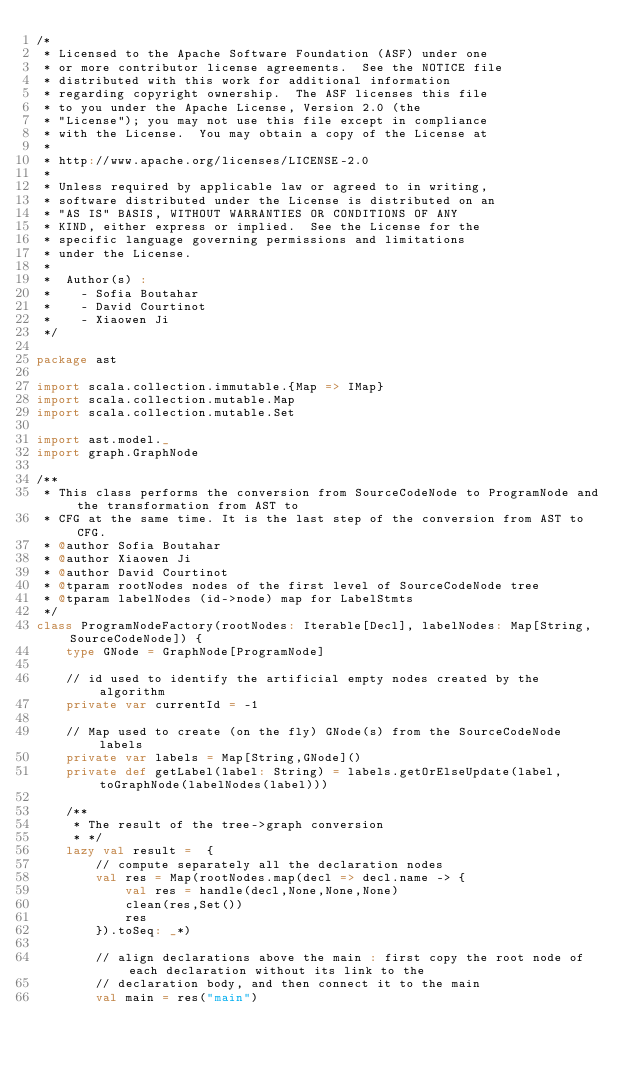<code> <loc_0><loc_0><loc_500><loc_500><_Scala_>/*
 * Licensed to the Apache Software Foundation (ASF) under one
 * or more contributor license agreements.  See the NOTICE file
 * distributed with this work for additional information
 * regarding copyright ownership.  The ASF licenses this file
 * to you under the Apache License, Version 2.0 (the
 * "License"); you may not use this file except in compliance
 * with the License.  You may obtain a copy of the License at
 * 
 * http://www.apache.org/licenses/LICENSE-2.0
 * 
 * Unless required by applicable law or agreed to in writing,
 * software distributed under the License is distributed on an
 * "AS IS" BASIS, WITHOUT WARRANTIES OR CONDITIONS OF ANY
 * KIND, either express or implied.  See the License for the
 * specific language governing permissions and limitations
 * under the License.
 * 
 *	Author(s) :
 *	  - Sofia Boutahar
 *    - David Courtinot
 *    - Xiaowen Ji
 */

package ast

import scala.collection.immutable.{Map => IMap}
import scala.collection.mutable.Map
import scala.collection.mutable.Set

import ast.model._
import graph.GraphNode

/**
 * This class performs the conversion from SourceCodeNode to ProgramNode and the transformation from AST to
 * CFG at the same time. It is the last step of the conversion from AST to CFG.
 * @author Sofia Boutahar
 * @author Xiaowen Ji
 * @author David Courtinot
 * @tparam rootNodes nodes of the first level of SourceCodeNode tree
 * @tparam labelNodes (id->node) map for LabelStmts
 */
class ProgramNodeFactory(rootNodes: Iterable[Decl], labelNodes: Map[String,SourceCodeNode]) {
    type GNode = GraphNode[ProgramNode]
    
    // id used to identify the artificial empty nodes created by the algorithm
    private var currentId = -1
    
    // Map used to create (on the fly) GNode(s) from the SourceCodeNode labels 
    private var labels = Map[String,GNode]()
    private def getLabel(label: String) = labels.getOrElseUpdate(label,toGraphNode(labelNodes(label)))

    /**
     * The result of the tree->graph conversion
     * */
    lazy val result =  {
        // compute separately all the declaration nodes
        val res = Map(rootNodes.map(decl => decl.name -> {
            val res = handle(decl,None,None,None)
            clean(res,Set())
            res
        }).toSeq: _*)
        
        // align declarations above the main : first copy the root node of each declaration without its link to the
        // declaration body, and then connect it to the main
        val main = res("main")</code> 